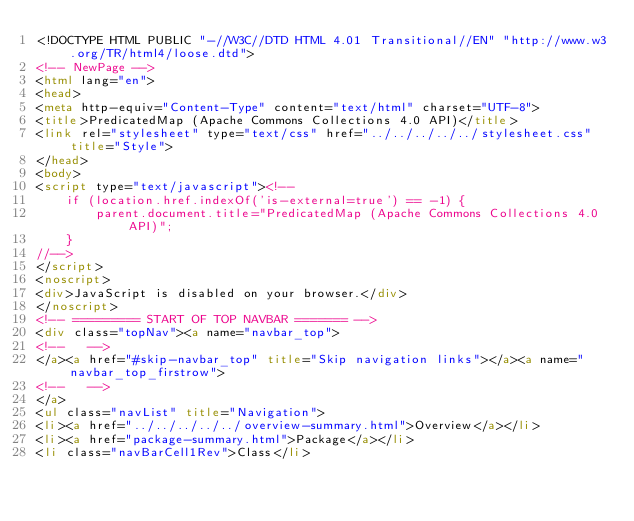Convert code to text. <code><loc_0><loc_0><loc_500><loc_500><_HTML_><!DOCTYPE HTML PUBLIC "-//W3C//DTD HTML 4.01 Transitional//EN" "http://www.w3.org/TR/html4/loose.dtd">
<!-- NewPage -->
<html lang="en">
<head>
<meta http-equiv="Content-Type" content="text/html" charset="UTF-8">
<title>PredicatedMap (Apache Commons Collections 4.0 API)</title>
<link rel="stylesheet" type="text/css" href="../../../../../stylesheet.css" title="Style">
</head>
<body>
<script type="text/javascript"><!--
    if (location.href.indexOf('is-external=true') == -1) {
        parent.document.title="PredicatedMap (Apache Commons Collections 4.0 API)";
    }
//-->
</script>
<noscript>
<div>JavaScript is disabled on your browser.</div>
</noscript>
<!-- ========= START OF TOP NAVBAR ======= -->
<div class="topNav"><a name="navbar_top">
<!--   -->
</a><a href="#skip-navbar_top" title="Skip navigation links"></a><a name="navbar_top_firstrow">
<!--   -->
</a>
<ul class="navList" title="Navigation">
<li><a href="../../../../../overview-summary.html">Overview</a></li>
<li><a href="package-summary.html">Package</a></li>
<li class="navBarCell1Rev">Class</li></code> 